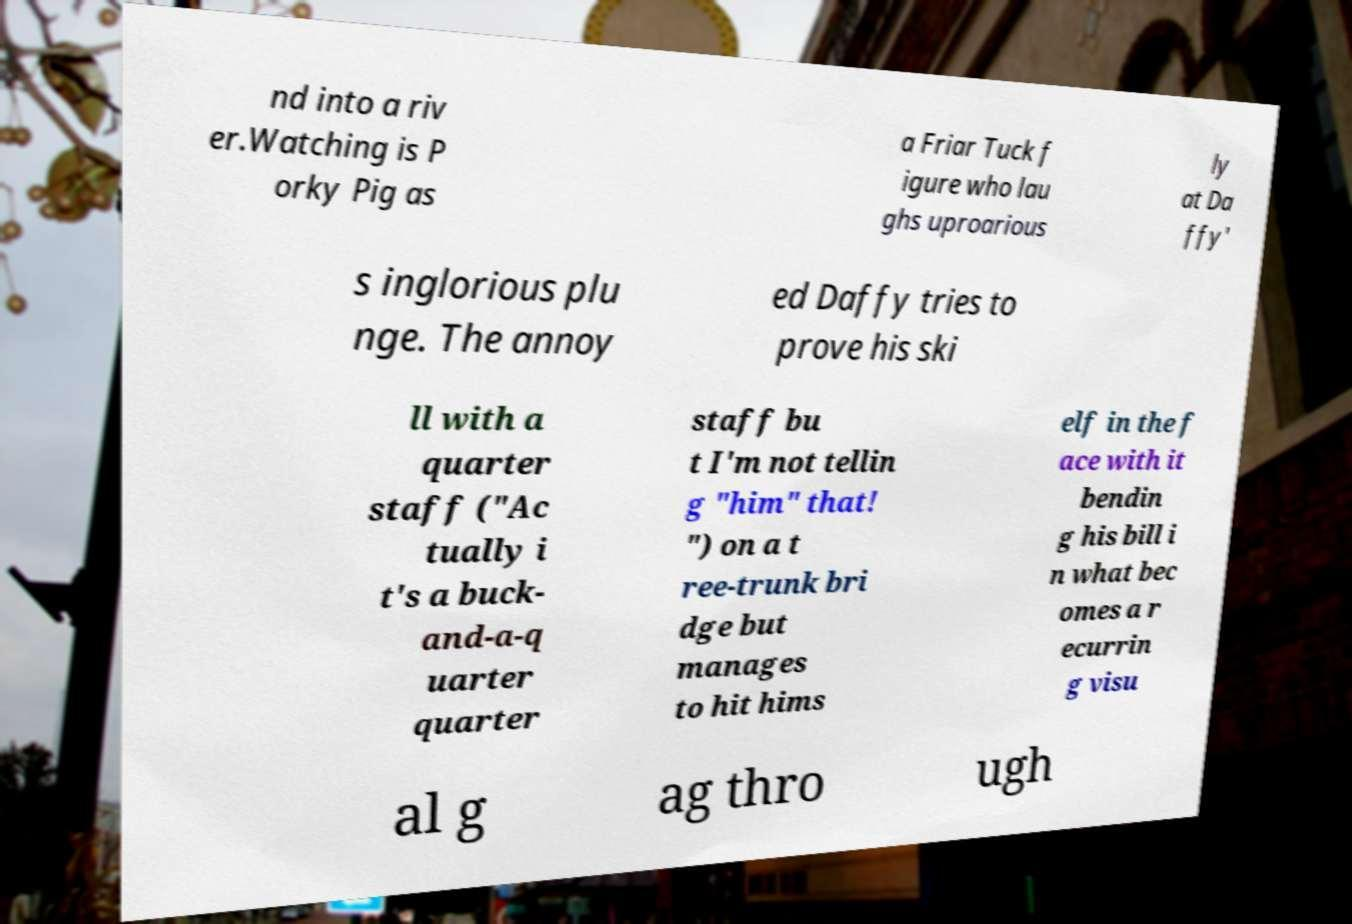Can you read and provide the text displayed in the image?This photo seems to have some interesting text. Can you extract and type it out for me? nd into a riv er.Watching is P orky Pig as a Friar Tuck f igure who lau ghs uproarious ly at Da ffy' s inglorious plu nge. The annoy ed Daffy tries to prove his ski ll with a quarter staff ("Ac tually i t's a buck- and-a-q uarter quarter staff bu t I'm not tellin g "him" that! ") on a t ree-trunk bri dge but manages to hit hims elf in the f ace with it bendin g his bill i n what bec omes a r ecurrin g visu al g ag thro ugh 